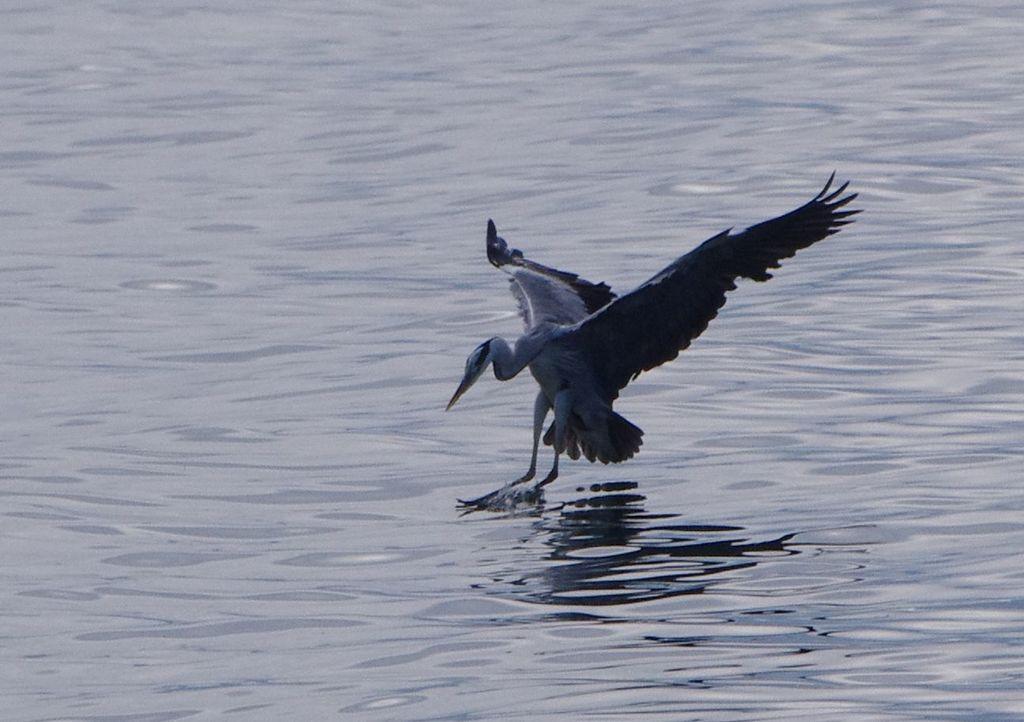Could you give a brief overview of what you see in this image? In this image there is a bird on the water. 